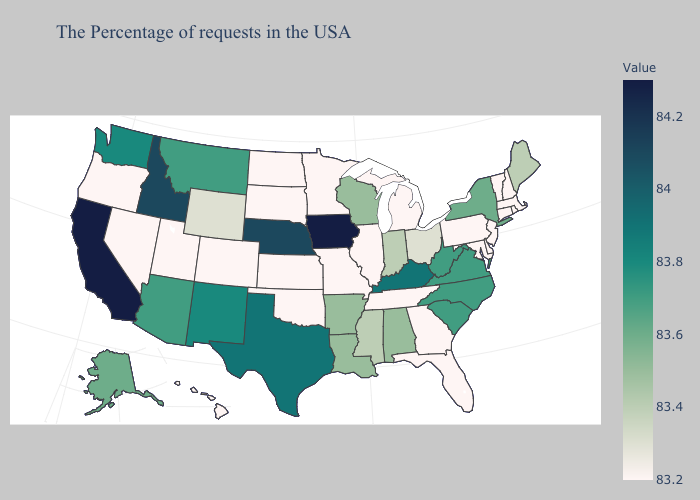Does Connecticut have the lowest value in the USA?
Give a very brief answer. Yes. Does Mississippi have the lowest value in the USA?
Quick response, please. No. Does North Carolina have the lowest value in the USA?
Quick response, please. No. Does West Virginia have a higher value than Kentucky?
Keep it brief. No. Does Rhode Island have a higher value than Washington?
Answer briefly. No. Does the map have missing data?
Be succinct. No. Does Michigan have the lowest value in the MidWest?
Give a very brief answer. Yes. Which states have the lowest value in the South?
Write a very short answer. Delaware, Maryland, Florida, Georgia, Tennessee, Oklahoma. Which states hav the highest value in the Northeast?
Write a very short answer. New York. 